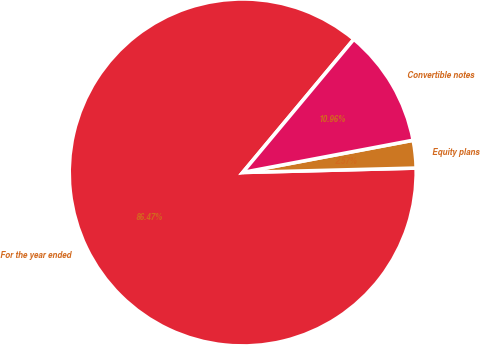Convert chart. <chart><loc_0><loc_0><loc_500><loc_500><pie_chart><fcel>For the year ended<fcel>Equity plans<fcel>Convertible notes<nl><fcel>86.46%<fcel>2.57%<fcel>10.96%<nl></chart> 